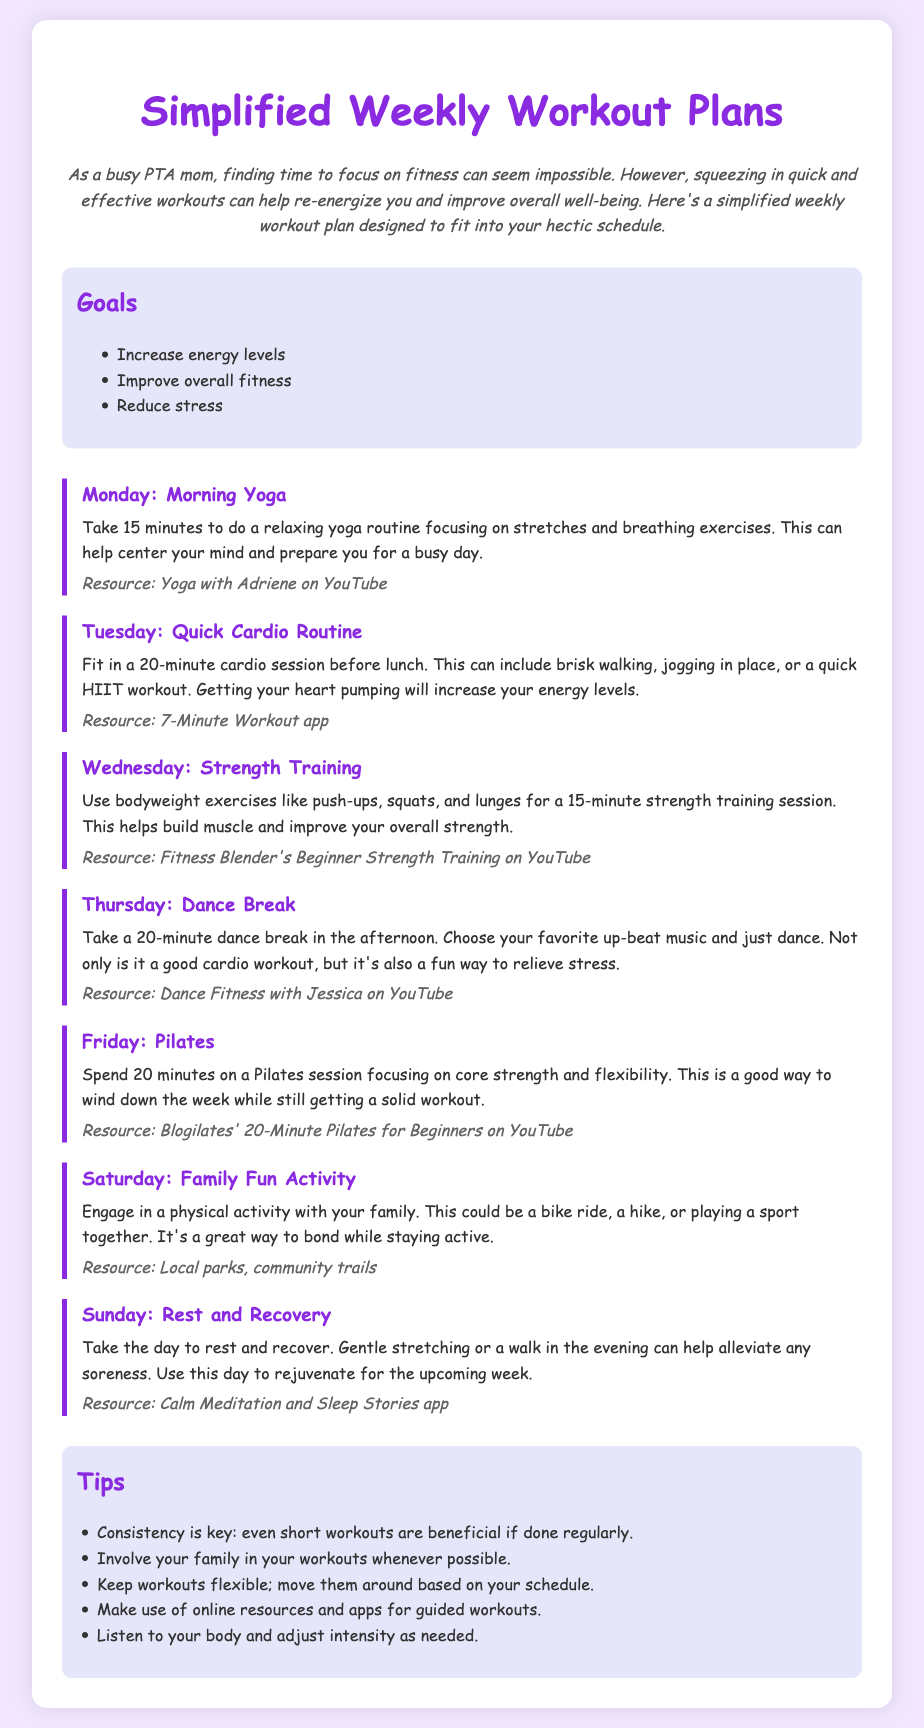What is the title of the document? The title clearly presented at the top of the document is "Simplified Weekly Workout Plans."
Answer: Simplified Weekly Workout Plans How many minutes is the morning yoga session? The document states that the morning yoga session should take 15 minutes.
Answer: 15 minutes What type of routine is suggested for Tuesday? The document specifies a "Quick Cardio Routine" for Tuesday.
Answer: Quick Cardio Routine Which day includes a family activity? Saturday is the day designated for a family fun activity.
Answer: Saturday What is one goal mentioned in the document? The document lists several goals, one of which is "Increase energy levels."
Answer: Increase energy levels How long should the Pilates session be? The document mentions that the Pilates session should last for 20 minutes.
Answer: 20 minutes What is the recommended resource for dance breaks? The resource suggested for dance breaks is "Dance Fitness with Jessica on YouTube."
Answer: Dance Fitness with Jessica on YouTube What is emphasized as important for workout consistency? The document emphasizes that "Consistency is key."
Answer: Consistency is key How should the Sunday be spent according to the plan? Sunday is designated as a day for "Rest and Recovery" in the workout plan.
Answer: Rest and Recovery 